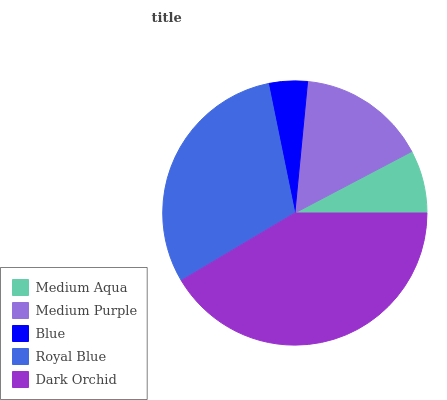Is Blue the minimum?
Answer yes or no. Yes. Is Dark Orchid the maximum?
Answer yes or no. Yes. Is Medium Purple the minimum?
Answer yes or no. No. Is Medium Purple the maximum?
Answer yes or no. No. Is Medium Purple greater than Medium Aqua?
Answer yes or no. Yes. Is Medium Aqua less than Medium Purple?
Answer yes or no. Yes. Is Medium Aqua greater than Medium Purple?
Answer yes or no. No. Is Medium Purple less than Medium Aqua?
Answer yes or no. No. Is Medium Purple the high median?
Answer yes or no. Yes. Is Medium Purple the low median?
Answer yes or no. Yes. Is Royal Blue the high median?
Answer yes or no. No. Is Royal Blue the low median?
Answer yes or no. No. 